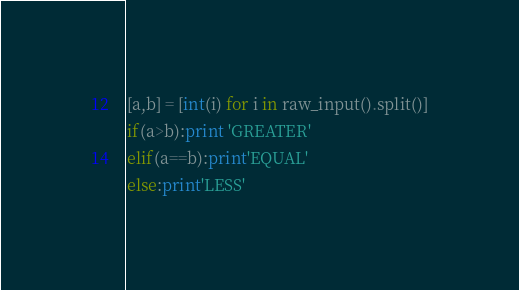Convert code to text. <code><loc_0><loc_0><loc_500><loc_500><_Python_>[a,b] = [int(i) for i in raw_input().split()]
if(a>b):print 'GREATER'
elif(a==b):print'EQUAL'
else:print'LESS'</code> 